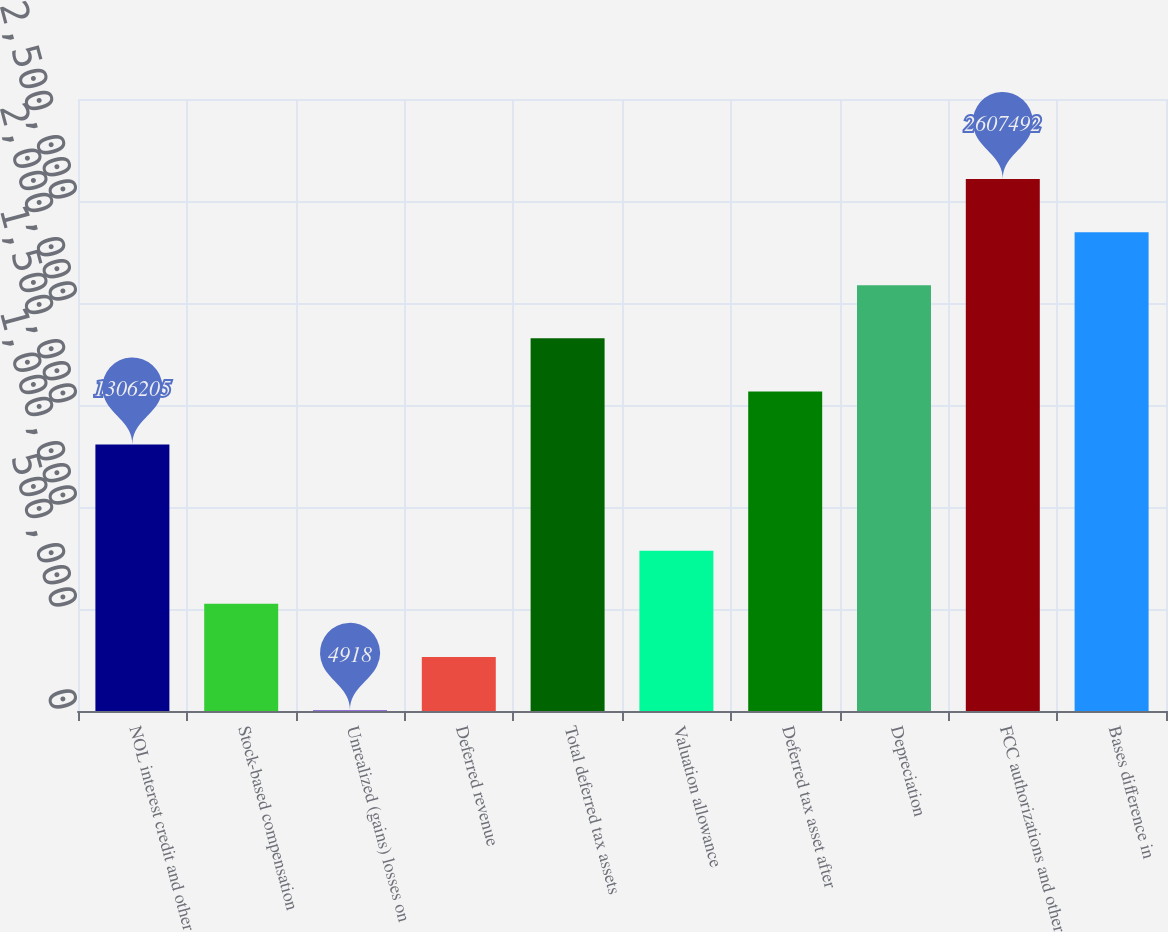Convert chart. <chart><loc_0><loc_0><loc_500><loc_500><bar_chart><fcel>NOL interest credit and other<fcel>Stock-based compensation<fcel>Unrealized (gains) losses on<fcel>Deferred revenue<fcel>Total deferred tax assets<fcel>Valuation allowance<fcel>Deferred tax asset after<fcel>Depreciation<fcel>FCC authorizations and other<fcel>Bases difference in<nl><fcel>1.3062e+06<fcel>525433<fcel>4918<fcel>265175<fcel>1.82672e+06<fcel>785690<fcel>1.56646e+06<fcel>2.08698e+06<fcel>2.60749e+06<fcel>2.34723e+06<nl></chart> 